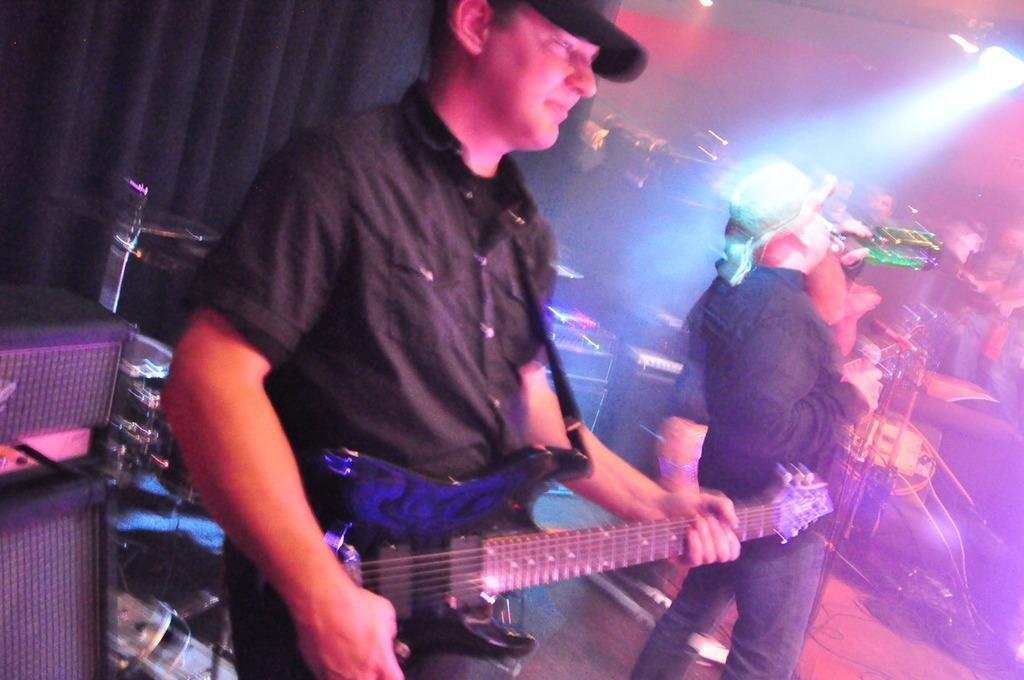What is the man in the image doing with the guitar? The man is standing and playing a guitar in the image. What is the other man doing in the image? The other man is singing with the help of a microphone in the image. What is the man singing holding in his hand? The man singing is holding a microphone in his hand. What is the man singing drinking in the image? The man singing is drinking water in the image. What can be seen on the roof in the image? There is a light on the roof in the image. What is the answer to the riddle that the man singing is telling in the image? There is no riddle mentioned in the image, so it is not possible to answer that question. 